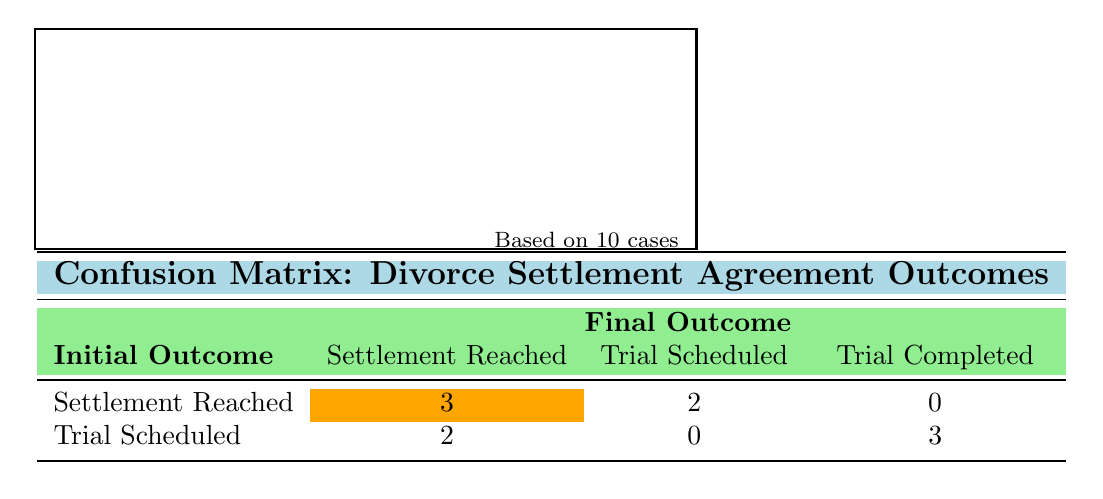What is the total number of cases where a settlement was reached initially? From the table, we can see the row for "Settlement Reached" under the Initial Outcome. It shows that there are three cases where the final outcome was also a settlement (3), and two cases where it was a trial scheduled (2). Adding these, we get a total of 3 + 2 = 5 cases.
Answer: 5 What is the number of cases where the final outcome was a trial completed? Looking at the "Trial Completed" column, we can see there are three cases listed under the row for "Trial Scheduled". Therefore, the total number of cases with a final outcome of trial completed is 3.
Answer: 3 How many cases resulted in a settlement reached after initially being scheduled for trial? The second column (Trial Scheduled) shows that there are 2 cases (case_id 4 and case_id 10) that started with a trial scheduled and ended with a settlement reached.
Answer: 2 Is it true that more cases reached a settlement than went to trial? First, count the cases where the final outcome was "Settlement Reached": there are 5 cases. Now, count the cases where the final outcome was "Trial Completed": there are 3 cases. Since 5 is greater than 3, it is true.
Answer: Yes What is the difference in the number of cases between those that reached a settlement and those that were scheduled for trial? Groups show that there are 5 cases that had a final outcome of "Settlement Reached" and 2 cases that had "Trial Scheduled." To find the difference, we subtract the scheduled trials from the settlements: 5 - 2 = 3.
Answer: 3 What percentage of cases initially scheduled for a trial resulted in a settlement reached? First, identify the number of cases scheduled for trial, which is 5 (2 that resulted in a settlement and 3 that completed a trial). Then we find the fraction of cases that resulted in settlements: 2 out of 5. To get the percentage, (2/5) * 100 = 40%.
Answer: 40% In total, how many unique final outcomes are listed in the table? The final outcomes listed in the table are "Settlement Reached", "Trial Scheduled", and "Trial Completed". There are no duplicates, so that counts as three unique outcomes.
Answer: 3 How many initial outcomes led to a settlement reached? By checking the "Settlement Reached" initial outcome row, there are 5 cases (3 settlements and 2 trials scheduled) that ultimately led to a settlement reached.
Answer: 5 How many cases were initially set for trial but settled instead? Reviewing the "Trial Scheduled" row, we see there are 2 cases (case_id 4 and case_id 10) that meet this criterion.
Answer: 2 